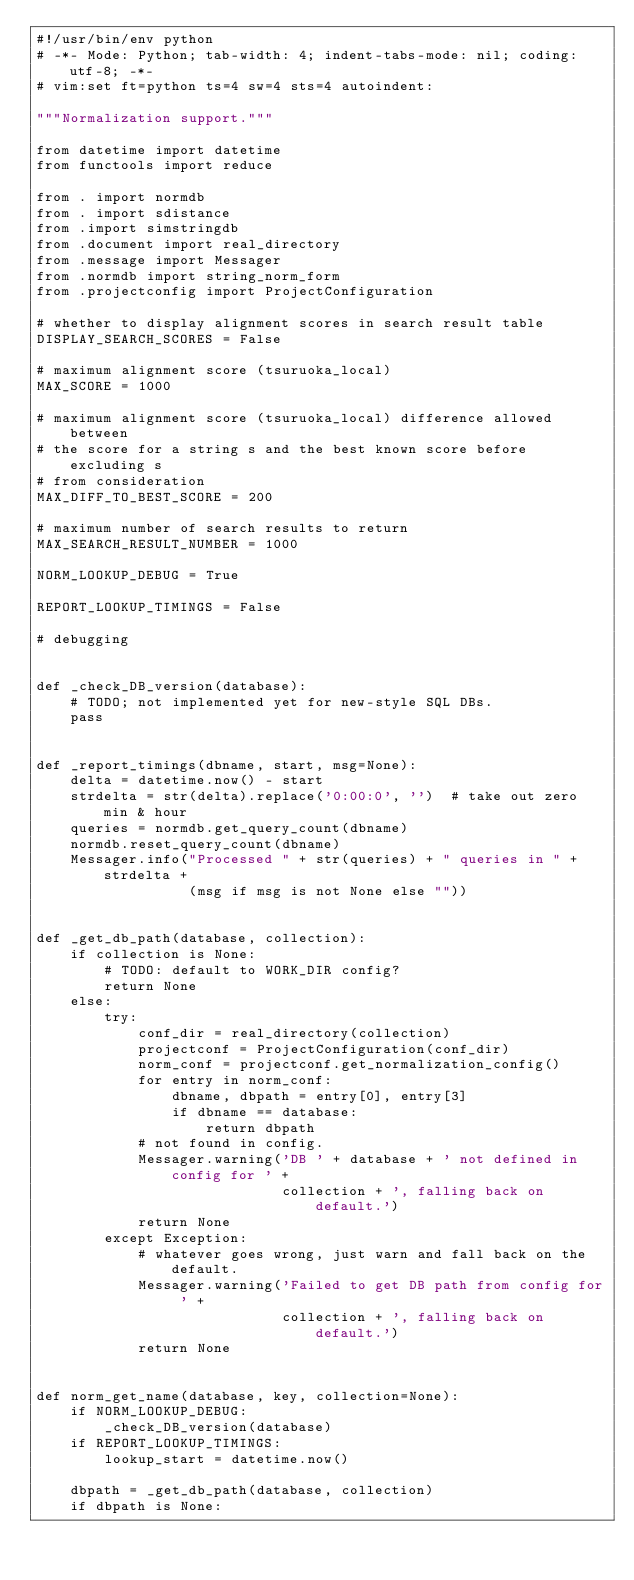Convert code to text. <code><loc_0><loc_0><loc_500><loc_500><_Python_>#!/usr/bin/env python
# -*- Mode: Python; tab-width: 4; indent-tabs-mode: nil; coding: utf-8; -*-
# vim:set ft=python ts=4 sw=4 sts=4 autoindent:

"""Normalization support."""

from datetime import datetime
from functools import reduce

from . import normdb
from . import sdistance
from .import simstringdb
from .document import real_directory
from .message import Messager
from .normdb import string_norm_form
from .projectconfig import ProjectConfiguration

# whether to display alignment scores in search result table
DISPLAY_SEARCH_SCORES = False

# maximum alignment score (tsuruoka_local)
MAX_SCORE = 1000

# maximum alignment score (tsuruoka_local) difference allowed between
# the score for a string s and the best known score before excluding s
# from consideration
MAX_DIFF_TO_BEST_SCORE = 200

# maximum number of search results to return
MAX_SEARCH_RESULT_NUMBER = 1000

NORM_LOOKUP_DEBUG = True

REPORT_LOOKUP_TIMINGS = False

# debugging


def _check_DB_version(database):
    # TODO; not implemented yet for new-style SQL DBs.
    pass


def _report_timings(dbname, start, msg=None):
    delta = datetime.now() - start
    strdelta = str(delta).replace('0:00:0', '')  # take out zero min & hour
    queries = normdb.get_query_count(dbname)
    normdb.reset_query_count(dbname)
    Messager.info("Processed " + str(queries) + " queries in " + strdelta +
                  (msg if msg is not None else ""))


def _get_db_path(database, collection):
    if collection is None:
        # TODO: default to WORK_DIR config?
        return None
    else:
        try:
            conf_dir = real_directory(collection)
            projectconf = ProjectConfiguration(conf_dir)
            norm_conf = projectconf.get_normalization_config()
            for entry in norm_conf:
                dbname, dbpath = entry[0], entry[3]
                if dbname == database:
                    return dbpath
            # not found in config.
            Messager.warning('DB ' + database + ' not defined in config for ' +
                             collection + ', falling back on default.')
            return None
        except Exception:
            # whatever goes wrong, just warn and fall back on the default.
            Messager.warning('Failed to get DB path from config for ' +
                             collection + ', falling back on default.')
            return None


def norm_get_name(database, key, collection=None):
    if NORM_LOOKUP_DEBUG:
        _check_DB_version(database)
    if REPORT_LOOKUP_TIMINGS:
        lookup_start = datetime.now()

    dbpath = _get_db_path(database, collection)
    if dbpath is None:</code> 